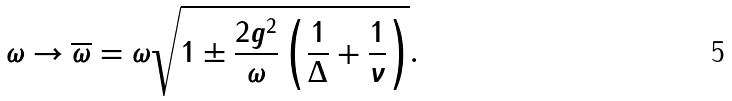<formula> <loc_0><loc_0><loc_500><loc_500>\omega \to \overline { \omega } = \omega \sqrt { 1 \pm \frac { 2 g ^ { 2 } } { \omega } \left ( \frac { 1 } { \Delta } + \frac { 1 } { \nu } \right ) } .</formula> 